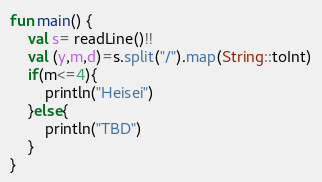Convert code to text. <code><loc_0><loc_0><loc_500><loc_500><_Kotlin_>fun main() {
    val s= readLine()!!
    val (y,m,d)=s.split("/").map(String::toInt)
    if(m<=4){
        println("Heisei")
    }else{
        println("TBD")
    }
}</code> 